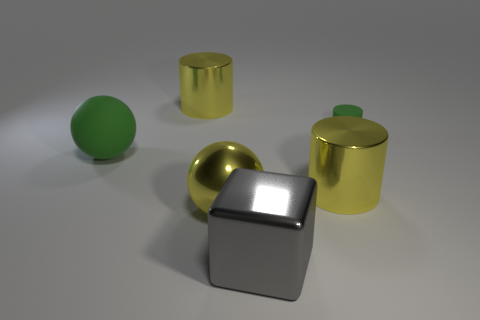The big metal cylinder in front of the big green rubber sphere is what color?
Offer a terse response. Yellow. Is there a yellow metallic thing of the same shape as the big green rubber object?
Ensure brevity in your answer.  Yes. What material is the big gray block?
Keep it short and to the point. Metal. How big is the thing that is both behind the green sphere and to the left of the yellow metallic ball?
Provide a short and direct response. Large. What is the material of the tiny thing that is the same color as the large rubber ball?
Keep it short and to the point. Rubber. What number of big green metallic cylinders are there?
Ensure brevity in your answer.  0. Is the number of big yellow shiny balls less than the number of small green rubber blocks?
Your answer should be very brief. No. There is a green thing that is the same size as the gray thing; what is it made of?
Ensure brevity in your answer.  Rubber. How many objects are cylinders or large gray objects?
Make the answer very short. 4. What number of big things are both in front of the tiny green matte cylinder and right of the green ball?
Ensure brevity in your answer.  3. 